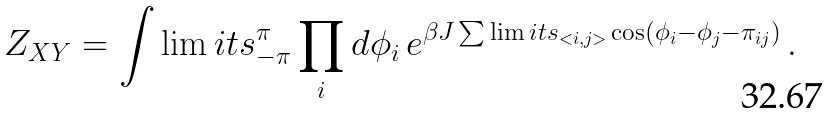Convert formula to latex. <formula><loc_0><loc_0><loc_500><loc_500>Z _ { X Y } = \int \lim i t s ^ { \pi } _ { - \pi } \prod _ { i } d \phi _ { i } \, e ^ { \beta J \sum \lim i t s _ { < i , j > } \cos ( \phi _ { i } - \phi _ { j } - \pi _ { i j } ) } \, .</formula> 